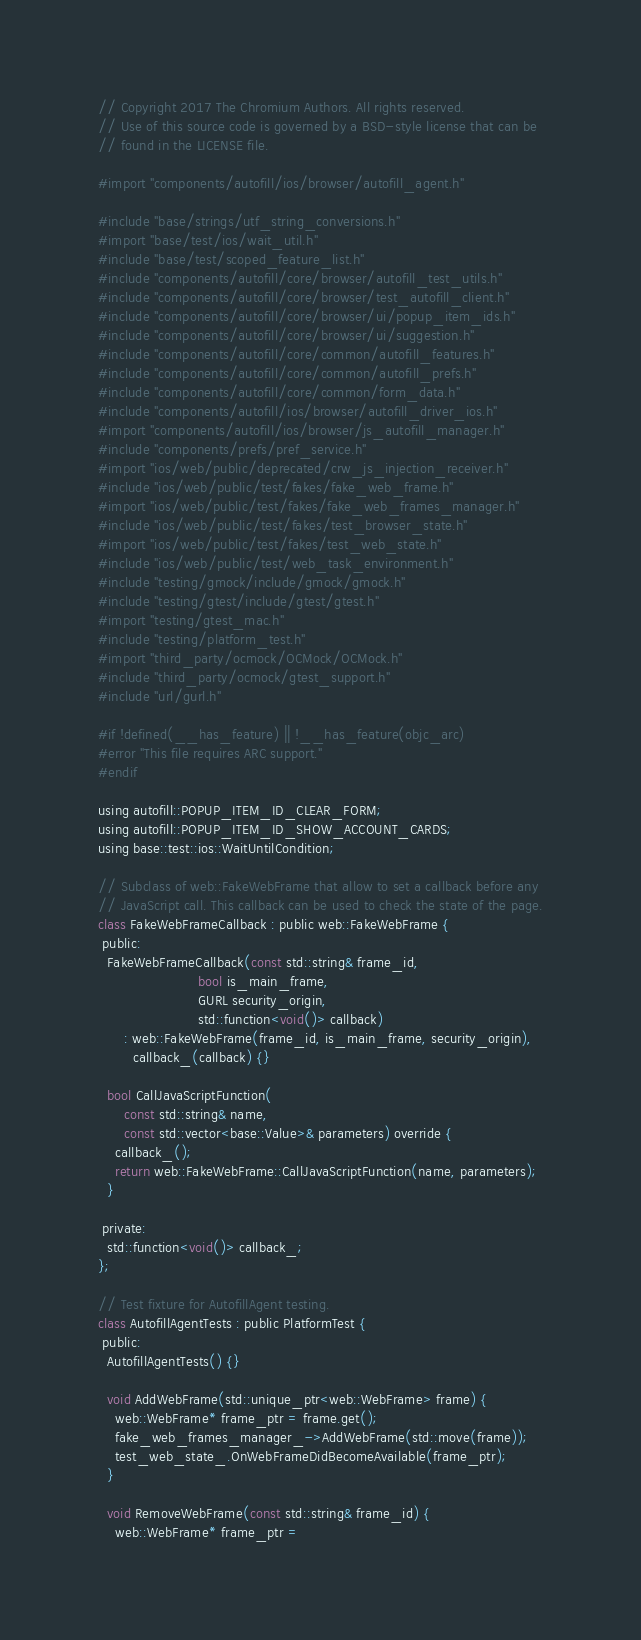<code> <loc_0><loc_0><loc_500><loc_500><_ObjectiveC_>// Copyright 2017 The Chromium Authors. All rights reserved.
// Use of this source code is governed by a BSD-style license that can be
// found in the LICENSE file.

#import "components/autofill/ios/browser/autofill_agent.h"

#include "base/strings/utf_string_conversions.h"
#import "base/test/ios/wait_util.h"
#include "base/test/scoped_feature_list.h"
#include "components/autofill/core/browser/autofill_test_utils.h"
#include "components/autofill/core/browser/test_autofill_client.h"
#include "components/autofill/core/browser/ui/popup_item_ids.h"
#include "components/autofill/core/browser/ui/suggestion.h"
#include "components/autofill/core/common/autofill_features.h"
#include "components/autofill/core/common/autofill_prefs.h"
#include "components/autofill/core/common/form_data.h"
#include "components/autofill/ios/browser/autofill_driver_ios.h"
#import "components/autofill/ios/browser/js_autofill_manager.h"
#include "components/prefs/pref_service.h"
#import "ios/web/public/deprecated/crw_js_injection_receiver.h"
#include "ios/web/public/test/fakes/fake_web_frame.h"
#import "ios/web/public/test/fakes/fake_web_frames_manager.h"
#include "ios/web/public/test/fakes/test_browser_state.h"
#import "ios/web/public/test/fakes/test_web_state.h"
#include "ios/web/public/test/web_task_environment.h"
#include "testing/gmock/include/gmock/gmock.h"
#include "testing/gtest/include/gtest/gtest.h"
#import "testing/gtest_mac.h"
#include "testing/platform_test.h"
#import "third_party/ocmock/OCMock/OCMock.h"
#include "third_party/ocmock/gtest_support.h"
#include "url/gurl.h"

#if !defined(__has_feature) || !__has_feature(objc_arc)
#error "This file requires ARC support."
#endif

using autofill::POPUP_ITEM_ID_CLEAR_FORM;
using autofill::POPUP_ITEM_ID_SHOW_ACCOUNT_CARDS;
using base::test::ios::WaitUntilCondition;

// Subclass of web::FakeWebFrame that allow to set a callback before any
// JavaScript call. This callback can be used to check the state of the page.
class FakeWebFrameCallback : public web::FakeWebFrame {
 public:
  FakeWebFrameCallback(const std::string& frame_id,
                       bool is_main_frame,
                       GURL security_origin,
                       std::function<void()> callback)
      : web::FakeWebFrame(frame_id, is_main_frame, security_origin),
        callback_(callback) {}

  bool CallJavaScriptFunction(
      const std::string& name,
      const std::vector<base::Value>& parameters) override {
    callback_();
    return web::FakeWebFrame::CallJavaScriptFunction(name, parameters);
  }

 private:
  std::function<void()> callback_;
};

// Test fixture for AutofillAgent testing.
class AutofillAgentTests : public PlatformTest {
 public:
  AutofillAgentTests() {}

  void AddWebFrame(std::unique_ptr<web::WebFrame> frame) {
    web::WebFrame* frame_ptr = frame.get();
    fake_web_frames_manager_->AddWebFrame(std::move(frame));
    test_web_state_.OnWebFrameDidBecomeAvailable(frame_ptr);
  }

  void RemoveWebFrame(const std::string& frame_id) {
    web::WebFrame* frame_ptr =</code> 